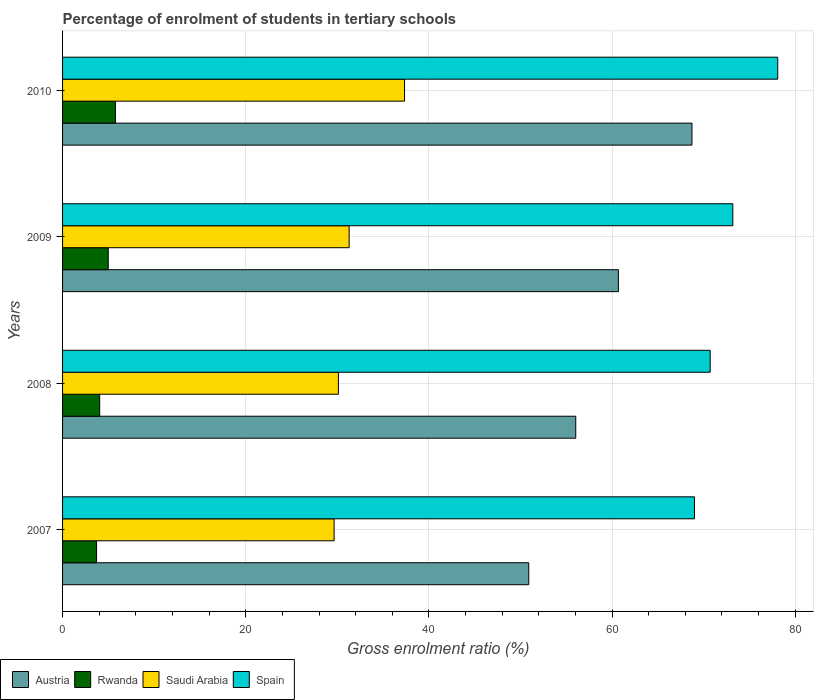How many groups of bars are there?
Make the answer very short. 4. How many bars are there on the 3rd tick from the top?
Offer a very short reply. 4. How many bars are there on the 1st tick from the bottom?
Your response must be concise. 4. What is the percentage of students enrolled in tertiary schools in Spain in 2008?
Give a very brief answer. 70.71. Across all years, what is the maximum percentage of students enrolled in tertiary schools in Austria?
Give a very brief answer. 68.72. Across all years, what is the minimum percentage of students enrolled in tertiary schools in Austria?
Keep it short and to the point. 50.9. In which year was the percentage of students enrolled in tertiary schools in Saudi Arabia maximum?
Your answer should be compact. 2010. In which year was the percentage of students enrolled in tertiary schools in Saudi Arabia minimum?
Offer a very short reply. 2007. What is the total percentage of students enrolled in tertiary schools in Saudi Arabia in the graph?
Make the answer very short. 128.4. What is the difference between the percentage of students enrolled in tertiary schools in Austria in 2007 and that in 2010?
Your answer should be compact. -17.82. What is the difference between the percentage of students enrolled in tertiary schools in Austria in 2009 and the percentage of students enrolled in tertiary schools in Spain in 2008?
Make the answer very short. -10.02. What is the average percentage of students enrolled in tertiary schools in Spain per year?
Offer a terse response. 72.74. In the year 2009, what is the difference between the percentage of students enrolled in tertiary schools in Saudi Arabia and percentage of students enrolled in tertiary schools in Rwanda?
Your response must be concise. 26.3. In how many years, is the percentage of students enrolled in tertiary schools in Spain greater than 8 %?
Your answer should be very brief. 4. What is the ratio of the percentage of students enrolled in tertiary schools in Austria in 2009 to that in 2010?
Offer a terse response. 0.88. Is the percentage of students enrolled in tertiary schools in Rwanda in 2007 less than that in 2009?
Your answer should be very brief. Yes. Is the difference between the percentage of students enrolled in tertiary schools in Saudi Arabia in 2009 and 2010 greater than the difference between the percentage of students enrolled in tertiary schools in Rwanda in 2009 and 2010?
Your response must be concise. No. What is the difference between the highest and the second highest percentage of students enrolled in tertiary schools in Saudi Arabia?
Make the answer very short. 6.05. What is the difference between the highest and the lowest percentage of students enrolled in tertiary schools in Spain?
Your answer should be compact. 9.09. Is the sum of the percentage of students enrolled in tertiary schools in Austria in 2007 and 2008 greater than the maximum percentage of students enrolled in tertiary schools in Saudi Arabia across all years?
Provide a succinct answer. Yes. Is it the case that in every year, the sum of the percentage of students enrolled in tertiary schools in Saudi Arabia and percentage of students enrolled in tertiary schools in Austria is greater than the sum of percentage of students enrolled in tertiary schools in Spain and percentage of students enrolled in tertiary schools in Rwanda?
Provide a short and direct response. Yes. What does the 1st bar from the bottom in 2010 represents?
Provide a short and direct response. Austria. Are all the bars in the graph horizontal?
Your response must be concise. Yes. How many years are there in the graph?
Give a very brief answer. 4. What is the difference between two consecutive major ticks on the X-axis?
Keep it short and to the point. 20. Are the values on the major ticks of X-axis written in scientific E-notation?
Give a very brief answer. No. Does the graph contain grids?
Make the answer very short. Yes. What is the title of the graph?
Provide a succinct answer. Percentage of enrolment of students in tertiary schools. Does "Least developed countries" appear as one of the legend labels in the graph?
Give a very brief answer. No. What is the label or title of the X-axis?
Make the answer very short. Gross enrolment ratio (%). What is the label or title of the Y-axis?
Offer a terse response. Years. What is the Gross enrolment ratio (%) in Austria in 2007?
Keep it short and to the point. 50.9. What is the Gross enrolment ratio (%) of Rwanda in 2007?
Your answer should be compact. 3.71. What is the Gross enrolment ratio (%) of Saudi Arabia in 2007?
Give a very brief answer. 29.65. What is the Gross enrolment ratio (%) in Spain in 2007?
Keep it short and to the point. 68.99. What is the Gross enrolment ratio (%) of Austria in 2008?
Your answer should be very brief. 56.03. What is the Gross enrolment ratio (%) of Rwanda in 2008?
Your answer should be compact. 4.05. What is the Gross enrolment ratio (%) in Saudi Arabia in 2008?
Your answer should be compact. 30.12. What is the Gross enrolment ratio (%) in Spain in 2008?
Keep it short and to the point. 70.71. What is the Gross enrolment ratio (%) in Austria in 2009?
Offer a terse response. 60.69. What is the Gross enrolment ratio (%) of Rwanda in 2009?
Make the answer very short. 4.99. What is the Gross enrolment ratio (%) in Saudi Arabia in 2009?
Provide a succinct answer. 31.29. What is the Gross enrolment ratio (%) of Spain in 2009?
Give a very brief answer. 73.18. What is the Gross enrolment ratio (%) in Austria in 2010?
Ensure brevity in your answer.  68.72. What is the Gross enrolment ratio (%) in Rwanda in 2010?
Your answer should be compact. 5.77. What is the Gross enrolment ratio (%) in Saudi Arabia in 2010?
Offer a very short reply. 37.34. What is the Gross enrolment ratio (%) of Spain in 2010?
Keep it short and to the point. 78.09. Across all years, what is the maximum Gross enrolment ratio (%) of Austria?
Your answer should be compact. 68.72. Across all years, what is the maximum Gross enrolment ratio (%) of Rwanda?
Your answer should be very brief. 5.77. Across all years, what is the maximum Gross enrolment ratio (%) of Saudi Arabia?
Offer a very short reply. 37.34. Across all years, what is the maximum Gross enrolment ratio (%) of Spain?
Ensure brevity in your answer.  78.09. Across all years, what is the minimum Gross enrolment ratio (%) in Austria?
Offer a terse response. 50.9. Across all years, what is the minimum Gross enrolment ratio (%) of Rwanda?
Your answer should be compact. 3.71. Across all years, what is the minimum Gross enrolment ratio (%) of Saudi Arabia?
Offer a terse response. 29.65. Across all years, what is the minimum Gross enrolment ratio (%) in Spain?
Offer a terse response. 68.99. What is the total Gross enrolment ratio (%) of Austria in the graph?
Provide a short and direct response. 236.35. What is the total Gross enrolment ratio (%) of Rwanda in the graph?
Offer a terse response. 18.53. What is the total Gross enrolment ratio (%) in Saudi Arabia in the graph?
Provide a succinct answer. 128.4. What is the total Gross enrolment ratio (%) in Spain in the graph?
Your answer should be compact. 290.97. What is the difference between the Gross enrolment ratio (%) in Austria in 2007 and that in 2008?
Your answer should be compact. -5.13. What is the difference between the Gross enrolment ratio (%) in Rwanda in 2007 and that in 2008?
Give a very brief answer. -0.34. What is the difference between the Gross enrolment ratio (%) in Saudi Arabia in 2007 and that in 2008?
Your response must be concise. -0.47. What is the difference between the Gross enrolment ratio (%) of Spain in 2007 and that in 2008?
Your answer should be compact. -1.72. What is the difference between the Gross enrolment ratio (%) of Austria in 2007 and that in 2009?
Offer a terse response. -9.79. What is the difference between the Gross enrolment ratio (%) of Rwanda in 2007 and that in 2009?
Offer a very short reply. -1.28. What is the difference between the Gross enrolment ratio (%) in Saudi Arabia in 2007 and that in 2009?
Keep it short and to the point. -1.64. What is the difference between the Gross enrolment ratio (%) of Spain in 2007 and that in 2009?
Provide a succinct answer. -4.19. What is the difference between the Gross enrolment ratio (%) of Austria in 2007 and that in 2010?
Give a very brief answer. -17.82. What is the difference between the Gross enrolment ratio (%) in Rwanda in 2007 and that in 2010?
Your answer should be very brief. -2.06. What is the difference between the Gross enrolment ratio (%) of Saudi Arabia in 2007 and that in 2010?
Your response must be concise. -7.69. What is the difference between the Gross enrolment ratio (%) of Spain in 2007 and that in 2010?
Your answer should be very brief. -9.09. What is the difference between the Gross enrolment ratio (%) in Austria in 2008 and that in 2009?
Make the answer very short. -4.66. What is the difference between the Gross enrolment ratio (%) in Rwanda in 2008 and that in 2009?
Offer a very short reply. -0.94. What is the difference between the Gross enrolment ratio (%) in Saudi Arabia in 2008 and that in 2009?
Offer a very short reply. -1.17. What is the difference between the Gross enrolment ratio (%) of Spain in 2008 and that in 2009?
Your answer should be compact. -2.47. What is the difference between the Gross enrolment ratio (%) of Austria in 2008 and that in 2010?
Provide a succinct answer. -12.69. What is the difference between the Gross enrolment ratio (%) in Rwanda in 2008 and that in 2010?
Provide a succinct answer. -1.72. What is the difference between the Gross enrolment ratio (%) in Saudi Arabia in 2008 and that in 2010?
Your response must be concise. -7.22. What is the difference between the Gross enrolment ratio (%) in Spain in 2008 and that in 2010?
Provide a short and direct response. -7.37. What is the difference between the Gross enrolment ratio (%) in Austria in 2009 and that in 2010?
Give a very brief answer. -8.03. What is the difference between the Gross enrolment ratio (%) in Rwanda in 2009 and that in 2010?
Your answer should be very brief. -0.78. What is the difference between the Gross enrolment ratio (%) of Saudi Arabia in 2009 and that in 2010?
Keep it short and to the point. -6.05. What is the difference between the Gross enrolment ratio (%) of Spain in 2009 and that in 2010?
Offer a very short reply. -4.9. What is the difference between the Gross enrolment ratio (%) of Austria in 2007 and the Gross enrolment ratio (%) of Rwanda in 2008?
Your response must be concise. 46.85. What is the difference between the Gross enrolment ratio (%) of Austria in 2007 and the Gross enrolment ratio (%) of Saudi Arabia in 2008?
Make the answer very short. 20.79. What is the difference between the Gross enrolment ratio (%) of Austria in 2007 and the Gross enrolment ratio (%) of Spain in 2008?
Provide a short and direct response. -19.81. What is the difference between the Gross enrolment ratio (%) in Rwanda in 2007 and the Gross enrolment ratio (%) in Saudi Arabia in 2008?
Ensure brevity in your answer.  -26.4. What is the difference between the Gross enrolment ratio (%) in Rwanda in 2007 and the Gross enrolment ratio (%) in Spain in 2008?
Your answer should be very brief. -67. What is the difference between the Gross enrolment ratio (%) of Saudi Arabia in 2007 and the Gross enrolment ratio (%) of Spain in 2008?
Keep it short and to the point. -41.06. What is the difference between the Gross enrolment ratio (%) in Austria in 2007 and the Gross enrolment ratio (%) in Rwanda in 2009?
Keep it short and to the point. 45.91. What is the difference between the Gross enrolment ratio (%) of Austria in 2007 and the Gross enrolment ratio (%) of Saudi Arabia in 2009?
Your answer should be compact. 19.61. What is the difference between the Gross enrolment ratio (%) of Austria in 2007 and the Gross enrolment ratio (%) of Spain in 2009?
Offer a very short reply. -22.28. What is the difference between the Gross enrolment ratio (%) in Rwanda in 2007 and the Gross enrolment ratio (%) in Saudi Arabia in 2009?
Ensure brevity in your answer.  -27.58. What is the difference between the Gross enrolment ratio (%) of Rwanda in 2007 and the Gross enrolment ratio (%) of Spain in 2009?
Provide a short and direct response. -69.47. What is the difference between the Gross enrolment ratio (%) in Saudi Arabia in 2007 and the Gross enrolment ratio (%) in Spain in 2009?
Give a very brief answer. -43.53. What is the difference between the Gross enrolment ratio (%) of Austria in 2007 and the Gross enrolment ratio (%) of Rwanda in 2010?
Offer a very short reply. 45.13. What is the difference between the Gross enrolment ratio (%) in Austria in 2007 and the Gross enrolment ratio (%) in Saudi Arabia in 2010?
Your response must be concise. 13.56. What is the difference between the Gross enrolment ratio (%) of Austria in 2007 and the Gross enrolment ratio (%) of Spain in 2010?
Keep it short and to the point. -27.18. What is the difference between the Gross enrolment ratio (%) of Rwanda in 2007 and the Gross enrolment ratio (%) of Saudi Arabia in 2010?
Make the answer very short. -33.63. What is the difference between the Gross enrolment ratio (%) of Rwanda in 2007 and the Gross enrolment ratio (%) of Spain in 2010?
Give a very brief answer. -74.37. What is the difference between the Gross enrolment ratio (%) in Saudi Arabia in 2007 and the Gross enrolment ratio (%) in Spain in 2010?
Give a very brief answer. -48.44. What is the difference between the Gross enrolment ratio (%) of Austria in 2008 and the Gross enrolment ratio (%) of Rwanda in 2009?
Your answer should be very brief. 51.04. What is the difference between the Gross enrolment ratio (%) of Austria in 2008 and the Gross enrolment ratio (%) of Saudi Arabia in 2009?
Your answer should be very brief. 24.74. What is the difference between the Gross enrolment ratio (%) in Austria in 2008 and the Gross enrolment ratio (%) in Spain in 2009?
Offer a terse response. -17.15. What is the difference between the Gross enrolment ratio (%) of Rwanda in 2008 and the Gross enrolment ratio (%) of Saudi Arabia in 2009?
Ensure brevity in your answer.  -27.24. What is the difference between the Gross enrolment ratio (%) of Rwanda in 2008 and the Gross enrolment ratio (%) of Spain in 2009?
Make the answer very short. -69.13. What is the difference between the Gross enrolment ratio (%) of Saudi Arabia in 2008 and the Gross enrolment ratio (%) of Spain in 2009?
Ensure brevity in your answer.  -43.07. What is the difference between the Gross enrolment ratio (%) of Austria in 2008 and the Gross enrolment ratio (%) of Rwanda in 2010?
Provide a succinct answer. 50.26. What is the difference between the Gross enrolment ratio (%) in Austria in 2008 and the Gross enrolment ratio (%) in Saudi Arabia in 2010?
Provide a short and direct response. 18.69. What is the difference between the Gross enrolment ratio (%) in Austria in 2008 and the Gross enrolment ratio (%) in Spain in 2010?
Provide a short and direct response. -22.05. What is the difference between the Gross enrolment ratio (%) of Rwanda in 2008 and the Gross enrolment ratio (%) of Saudi Arabia in 2010?
Make the answer very short. -33.29. What is the difference between the Gross enrolment ratio (%) in Rwanda in 2008 and the Gross enrolment ratio (%) in Spain in 2010?
Keep it short and to the point. -74.03. What is the difference between the Gross enrolment ratio (%) of Saudi Arabia in 2008 and the Gross enrolment ratio (%) of Spain in 2010?
Provide a succinct answer. -47.97. What is the difference between the Gross enrolment ratio (%) in Austria in 2009 and the Gross enrolment ratio (%) in Rwanda in 2010?
Offer a terse response. 54.92. What is the difference between the Gross enrolment ratio (%) of Austria in 2009 and the Gross enrolment ratio (%) of Saudi Arabia in 2010?
Offer a very short reply. 23.35. What is the difference between the Gross enrolment ratio (%) in Austria in 2009 and the Gross enrolment ratio (%) in Spain in 2010?
Your answer should be compact. -17.4. What is the difference between the Gross enrolment ratio (%) of Rwanda in 2009 and the Gross enrolment ratio (%) of Saudi Arabia in 2010?
Ensure brevity in your answer.  -32.35. What is the difference between the Gross enrolment ratio (%) in Rwanda in 2009 and the Gross enrolment ratio (%) in Spain in 2010?
Give a very brief answer. -73.1. What is the difference between the Gross enrolment ratio (%) in Saudi Arabia in 2009 and the Gross enrolment ratio (%) in Spain in 2010?
Your answer should be compact. -46.8. What is the average Gross enrolment ratio (%) in Austria per year?
Provide a succinct answer. 59.09. What is the average Gross enrolment ratio (%) in Rwanda per year?
Your response must be concise. 4.63. What is the average Gross enrolment ratio (%) of Saudi Arabia per year?
Provide a short and direct response. 32.1. What is the average Gross enrolment ratio (%) of Spain per year?
Keep it short and to the point. 72.74. In the year 2007, what is the difference between the Gross enrolment ratio (%) of Austria and Gross enrolment ratio (%) of Rwanda?
Your answer should be very brief. 47.19. In the year 2007, what is the difference between the Gross enrolment ratio (%) of Austria and Gross enrolment ratio (%) of Saudi Arabia?
Keep it short and to the point. 21.25. In the year 2007, what is the difference between the Gross enrolment ratio (%) in Austria and Gross enrolment ratio (%) in Spain?
Make the answer very short. -18.09. In the year 2007, what is the difference between the Gross enrolment ratio (%) of Rwanda and Gross enrolment ratio (%) of Saudi Arabia?
Your answer should be very brief. -25.94. In the year 2007, what is the difference between the Gross enrolment ratio (%) in Rwanda and Gross enrolment ratio (%) in Spain?
Provide a short and direct response. -65.28. In the year 2007, what is the difference between the Gross enrolment ratio (%) in Saudi Arabia and Gross enrolment ratio (%) in Spain?
Your answer should be compact. -39.34. In the year 2008, what is the difference between the Gross enrolment ratio (%) of Austria and Gross enrolment ratio (%) of Rwanda?
Your response must be concise. 51.98. In the year 2008, what is the difference between the Gross enrolment ratio (%) in Austria and Gross enrolment ratio (%) in Saudi Arabia?
Offer a terse response. 25.92. In the year 2008, what is the difference between the Gross enrolment ratio (%) of Austria and Gross enrolment ratio (%) of Spain?
Your response must be concise. -14.68. In the year 2008, what is the difference between the Gross enrolment ratio (%) in Rwanda and Gross enrolment ratio (%) in Saudi Arabia?
Your answer should be compact. -26.06. In the year 2008, what is the difference between the Gross enrolment ratio (%) in Rwanda and Gross enrolment ratio (%) in Spain?
Provide a short and direct response. -66.66. In the year 2008, what is the difference between the Gross enrolment ratio (%) in Saudi Arabia and Gross enrolment ratio (%) in Spain?
Provide a short and direct response. -40.6. In the year 2009, what is the difference between the Gross enrolment ratio (%) in Austria and Gross enrolment ratio (%) in Rwanda?
Your response must be concise. 55.7. In the year 2009, what is the difference between the Gross enrolment ratio (%) of Austria and Gross enrolment ratio (%) of Saudi Arabia?
Offer a very short reply. 29.4. In the year 2009, what is the difference between the Gross enrolment ratio (%) of Austria and Gross enrolment ratio (%) of Spain?
Keep it short and to the point. -12.49. In the year 2009, what is the difference between the Gross enrolment ratio (%) of Rwanda and Gross enrolment ratio (%) of Saudi Arabia?
Keep it short and to the point. -26.3. In the year 2009, what is the difference between the Gross enrolment ratio (%) of Rwanda and Gross enrolment ratio (%) of Spain?
Your answer should be very brief. -68.19. In the year 2009, what is the difference between the Gross enrolment ratio (%) of Saudi Arabia and Gross enrolment ratio (%) of Spain?
Offer a terse response. -41.89. In the year 2010, what is the difference between the Gross enrolment ratio (%) in Austria and Gross enrolment ratio (%) in Rwanda?
Provide a short and direct response. 62.95. In the year 2010, what is the difference between the Gross enrolment ratio (%) in Austria and Gross enrolment ratio (%) in Saudi Arabia?
Ensure brevity in your answer.  31.38. In the year 2010, what is the difference between the Gross enrolment ratio (%) of Austria and Gross enrolment ratio (%) of Spain?
Your response must be concise. -9.36. In the year 2010, what is the difference between the Gross enrolment ratio (%) in Rwanda and Gross enrolment ratio (%) in Saudi Arabia?
Provide a succinct answer. -31.57. In the year 2010, what is the difference between the Gross enrolment ratio (%) of Rwanda and Gross enrolment ratio (%) of Spain?
Your answer should be compact. -72.31. In the year 2010, what is the difference between the Gross enrolment ratio (%) in Saudi Arabia and Gross enrolment ratio (%) in Spain?
Offer a terse response. -40.75. What is the ratio of the Gross enrolment ratio (%) in Austria in 2007 to that in 2008?
Provide a succinct answer. 0.91. What is the ratio of the Gross enrolment ratio (%) in Rwanda in 2007 to that in 2008?
Offer a very short reply. 0.92. What is the ratio of the Gross enrolment ratio (%) of Saudi Arabia in 2007 to that in 2008?
Make the answer very short. 0.98. What is the ratio of the Gross enrolment ratio (%) in Spain in 2007 to that in 2008?
Provide a succinct answer. 0.98. What is the ratio of the Gross enrolment ratio (%) of Austria in 2007 to that in 2009?
Offer a terse response. 0.84. What is the ratio of the Gross enrolment ratio (%) in Rwanda in 2007 to that in 2009?
Provide a short and direct response. 0.74. What is the ratio of the Gross enrolment ratio (%) in Saudi Arabia in 2007 to that in 2009?
Your response must be concise. 0.95. What is the ratio of the Gross enrolment ratio (%) of Spain in 2007 to that in 2009?
Your answer should be very brief. 0.94. What is the ratio of the Gross enrolment ratio (%) in Austria in 2007 to that in 2010?
Your answer should be compact. 0.74. What is the ratio of the Gross enrolment ratio (%) in Rwanda in 2007 to that in 2010?
Your response must be concise. 0.64. What is the ratio of the Gross enrolment ratio (%) of Saudi Arabia in 2007 to that in 2010?
Your answer should be compact. 0.79. What is the ratio of the Gross enrolment ratio (%) in Spain in 2007 to that in 2010?
Keep it short and to the point. 0.88. What is the ratio of the Gross enrolment ratio (%) in Austria in 2008 to that in 2009?
Offer a terse response. 0.92. What is the ratio of the Gross enrolment ratio (%) of Rwanda in 2008 to that in 2009?
Offer a very short reply. 0.81. What is the ratio of the Gross enrolment ratio (%) of Saudi Arabia in 2008 to that in 2009?
Your answer should be very brief. 0.96. What is the ratio of the Gross enrolment ratio (%) in Spain in 2008 to that in 2009?
Offer a very short reply. 0.97. What is the ratio of the Gross enrolment ratio (%) of Austria in 2008 to that in 2010?
Keep it short and to the point. 0.82. What is the ratio of the Gross enrolment ratio (%) of Rwanda in 2008 to that in 2010?
Ensure brevity in your answer.  0.7. What is the ratio of the Gross enrolment ratio (%) in Saudi Arabia in 2008 to that in 2010?
Your response must be concise. 0.81. What is the ratio of the Gross enrolment ratio (%) in Spain in 2008 to that in 2010?
Your answer should be compact. 0.91. What is the ratio of the Gross enrolment ratio (%) of Austria in 2009 to that in 2010?
Your response must be concise. 0.88. What is the ratio of the Gross enrolment ratio (%) in Rwanda in 2009 to that in 2010?
Ensure brevity in your answer.  0.86. What is the ratio of the Gross enrolment ratio (%) of Saudi Arabia in 2009 to that in 2010?
Your response must be concise. 0.84. What is the ratio of the Gross enrolment ratio (%) in Spain in 2009 to that in 2010?
Make the answer very short. 0.94. What is the difference between the highest and the second highest Gross enrolment ratio (%) in Austria?
Offer a very short reply. 8.03. What is the difference between the highest and the second highest Gross enrolment ratio (%) of Rwanda?
Give a very brief answer. 0.78. What is the difference between the highest and the second highest Gross enrolment ratio (%) in Saudi Arabia?
Your answer should be very brief. 6.05. What is the difference between the highest and the second highest Gross enrolment ratio (%) in Spain?
Make the answer very short. 4.9. What is the difference between the highest and the lowest Gross enrolment ratio (%) in Austria?
Give a very brief answer. 17.82. What is the difference between the highest and the lowest Gross enrolment ratio (%) of Rwanda?
Your answer should be compact. 2.06. What is the difference between the highest and the lowest Gross enrolment ratio (%) of Saudi Arabia?
Give a very brief answer. 7.69. What is the difference between the highest and the lowest Gross enrolment ratio (%) of Spain?
Give a very brief answer. 9.09. 